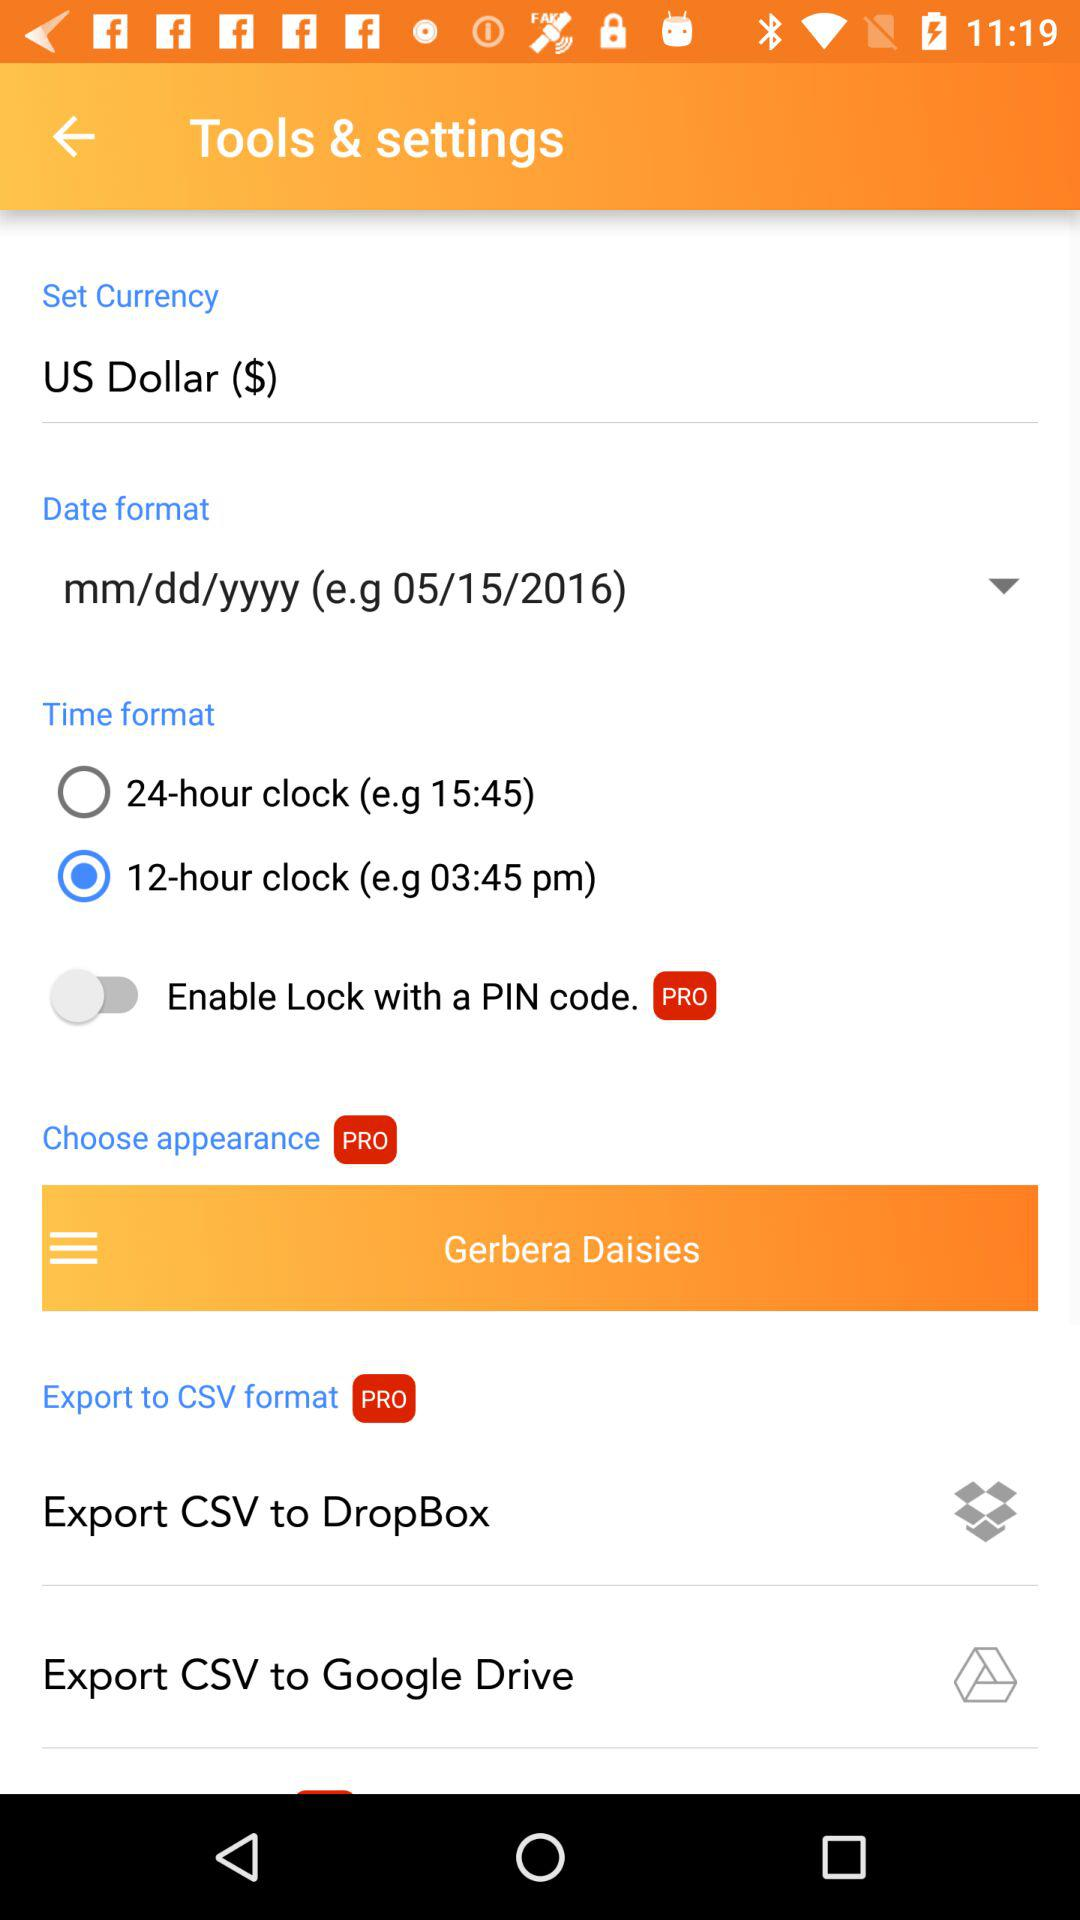What date is displayed on the screen? The displayed date is May 15, 2016. 